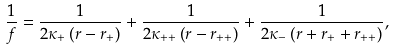<formula> <loc_0><loc_0><loc_500><loc_500>\frac { 1 } { f } = \frac { 1 } { 2 \kappa _ { + } \left ( r - r _ { + } \right ) } + \frac { 1 } { 2 \kappa _ { + + } \left ( r - r _ { + + } \right ) } + \frac { 1 } { 2 \kappa _ { - } \left ( r + r _ { + } + r _ { + + } \right ) } ,</formula> 